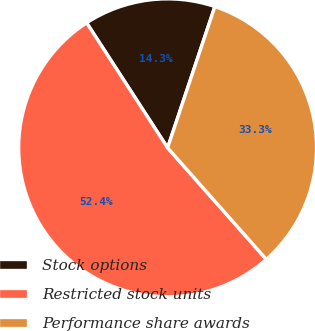<chart> <loc_0><loc_0><loc_500><loc_500><pie_chart><fcel>Stock options<fcel>Restricted stock units<fcel>Performance share awards<nl><fcel>14.29%<fcel>52.38%<fcel>33.33%<nl></chart> 